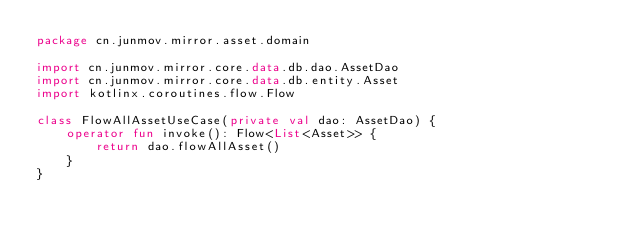<code> <loc_0><loc_0><loc_500><loc_500><_Kotlin_>package cn.junmov.mirror.asset.domain

import cn.junmov.mirror.core.data.db.dao.AssetDao
import cn.junmov.mirror.core.data.db.entity.Asset
import kotlinx.coroutines.flow.Flow

class FlowAllAssetUseCase(private val dao: AssetDao) {
    operator fun invoke(): Flow<List<Asset>> {
        return dao.flowAllAsset()
    }
}
</code> 